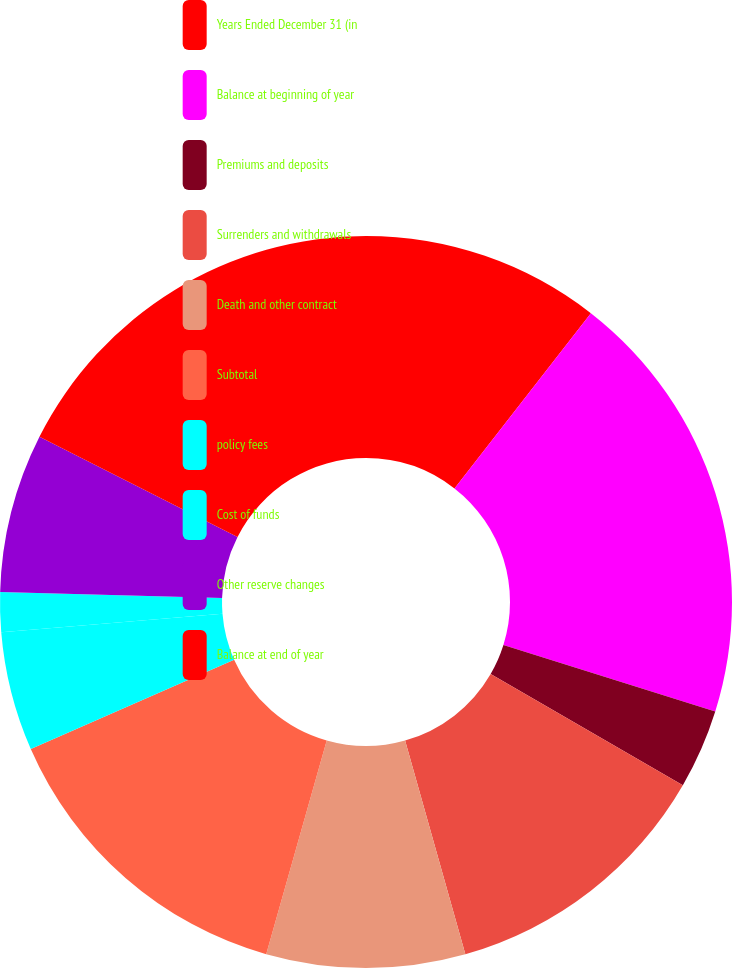<chart> <loc_0><loc_0><loc_500><loc_500><pie_chart><fcel>Years Ended December 31 (in<fcel>Balance at beginning of year<fcel>Premiums and deposits<fcel>Surrenders and withdrawals<fcel>Death and other contract<fcel>Subtotal<fcel>policy fees<fcel>Cost of funds<fcel>Other reserve changes<fcel>Balance at end of year<nl><fcel>10.53%<fcel>19.3%<fcel>3.51%<fcel>12.28%<fcel>8.77%<fcel>14.03%<fcel>5.26%<fcel>1.75%<fcel>7.02%<fcel>17.54%<nl></chart> 